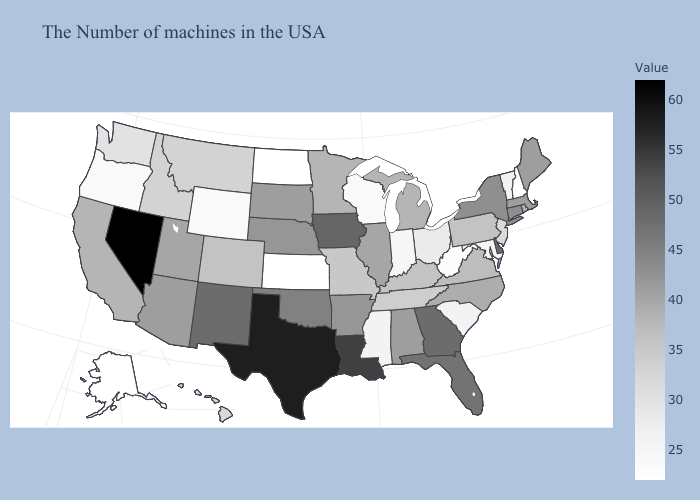Does North Carolina have the highest value in the South?
Give a very brief answer. No. 